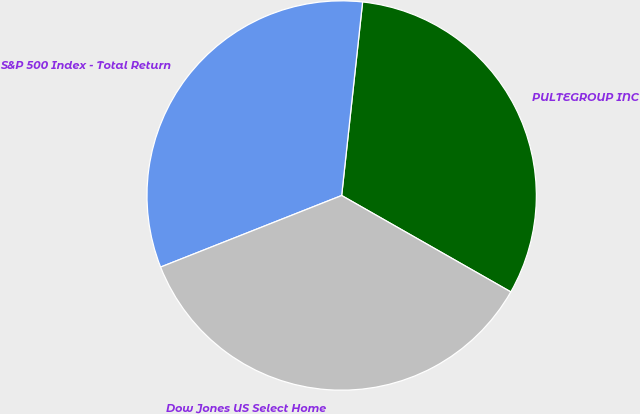Convert chart to OTSL. <chart><loc_0><loc_0><loc_500><loc_500><pie_chart><fcel>PULTEGROUP INC<fcel>S&P 500 Index - Total Return<fcel>Dow Jones US Select Home<nl><fcel>31.53%<fcel>32.71%<fcel>35.77%<nl></chart> 